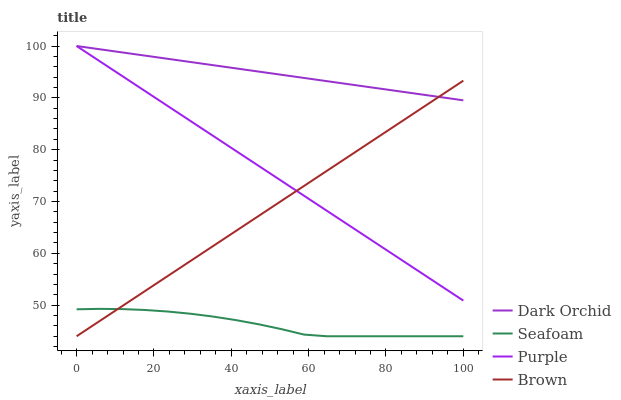Does Seafoam have the minimum area under the curve?
Answer yes or no. Yes. Does Dark Orchid have the maximum area under the curve?
Answer yes or no. Yes. Does Brown have the minimum area under the curve?
Answer yes or no. No. Does Brown have the maximum area under the curve?
Answer yes or no. No. Is Purple the smoothest?
Answer yes or no. Yes. Is Seafoam the roughest?
Answer yes or no. Yes. Is Brown the smoothest?
Answer yes or no. No. Is Brown the roughest?
Answer yes or no. No. Does Brown have the lowest value?
Answer yes or no. Yes. Does Dark Orchid have the lowest value?
Answer yes or no. No. Does Dark Orchid have the highest value?
Answer yes or no. Yes. Does Brown have the highest value?
Answer yes or no. No. Is Seafoam less than Dark Orchid?
Answer yes or no. Yes. Is Dark Orchid greater than Seafoam?
Answer yes or no. Yes. Does Brown intersect Seafoam?
Answer yes or no. Yes. Is Brown less than Seafoam?
Answer yes or no. No. Is Brown greater than Seafoam?
Answer yes or no. No. Does Seafoam intersect Dark Orchid?
Answer yes or no. No. 